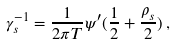Convert formula to latex. <formula><loc_0><loc_0><loc_500><loc_500>\gamma _ { s } ^ { - 1 } = \frac { 1 } { 2 \pi T } \psi ^ { \prime } ( \frac { 1 } { 2 } + \frac { \rho _ { s } } { 2 } ) \, ,</formula> 